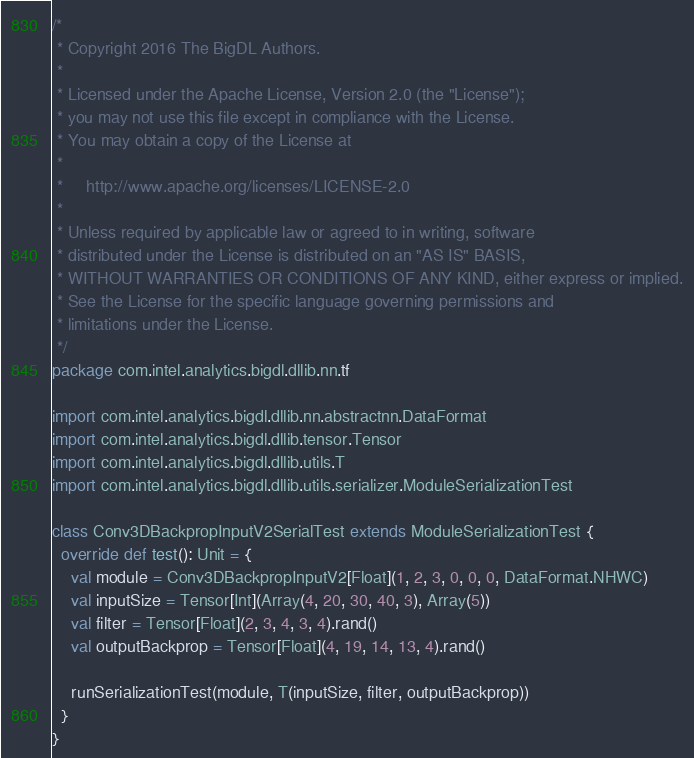<code> <loc_0><loc_0><loc_500><loc_500><_Scala_>/*
 * Copyright 2016 The BigDL Authors.
 *
 * Licensed under the Apache License, Version 2.0 (the "License");
 * you may not use this file except in compliance with the License.
 * You may obtain a copy of the License at
 *
 *     http://www.apache.org/licenses/LICENSE-2.0
 *
 * Unless required by applicable law or agreed to in writing, software
 * distributed under the License is distributed on an "AS IS" BASIS,
 * WITHOUT WARRANTIES OR CONDITIONS OF ANY KIND, either express or implied.
 * See the License for the specific language governing permissions and
 * limitations under the License.
 */
package com.intel.analytics.bigdl.dllib.nn.tf

import com.intel.analytics.bigdl.dllib.nn.abstractnn.DataFormat
import com.intel.analytics.bigdl.dllib.tensor.Tensor
import com.intel.analytics.bigdl.dllib.utils.T
import com.intel.analytics.bigdl.dllib.utils.serializer.ModuleSerializationTest

class Conv3DBackpropInputV2SerialTest extends ModuleSerializationTest {
  override def test(): Unit = {
    val module = Conv3DBackpropInputV2[Float](1, 2, 3, 0, 0, 0, DataFormat.NHWC)
    val inputSize = Tensor[Int](Array(4, 20, 30, 40, 3), Array(5))
    val filter = Tensor[Float](2, 3, 4, 3, 4).rand()
    val outputBackprop = Tensor[Float](4, 19, 14, 13, 4).rand()

    runSerializationTest(module, T(inputSize, filter, outputBackprop))
  }
}
</code> 